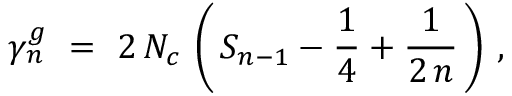Convert formula to latex. <formula><loc_0><loc_0><loc_500><loc_500>\gamma _ { n } ^ { g } \ = \ 2 \, N _ { c } \, \left ( \, S _ { n - 1 } - \frac { 1 } { 4 } + \frac { 1 } { 2 \, n } \, \right ) \, ,</formula> 